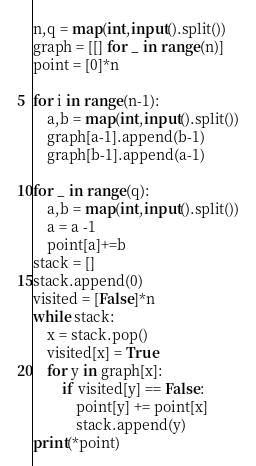<code> <loc_0><loc_0><loc_500><loc_500><_Python_>n,q = map(int,input().split())
graph = [[] for _ in range(n)]
point = [0]*n

for i in range(n-1):
    a,b = map(int,input().split())
    graph[a-1].append(b-1)
    graph[b-1].append(a-1)
    
for _ in range(q):
    a,b = map(int,input().split())
    a = a -1
    point[a]+=b
stack = []
stack.append(0)
visited = [False]*n
while stack:
    x = stack.pop()
    visited[x] = True
    for y in graph[x]:
        if visited[y] == False:
            point[y] += point[x]
            stack.append(y)
print(*point)
</code> 